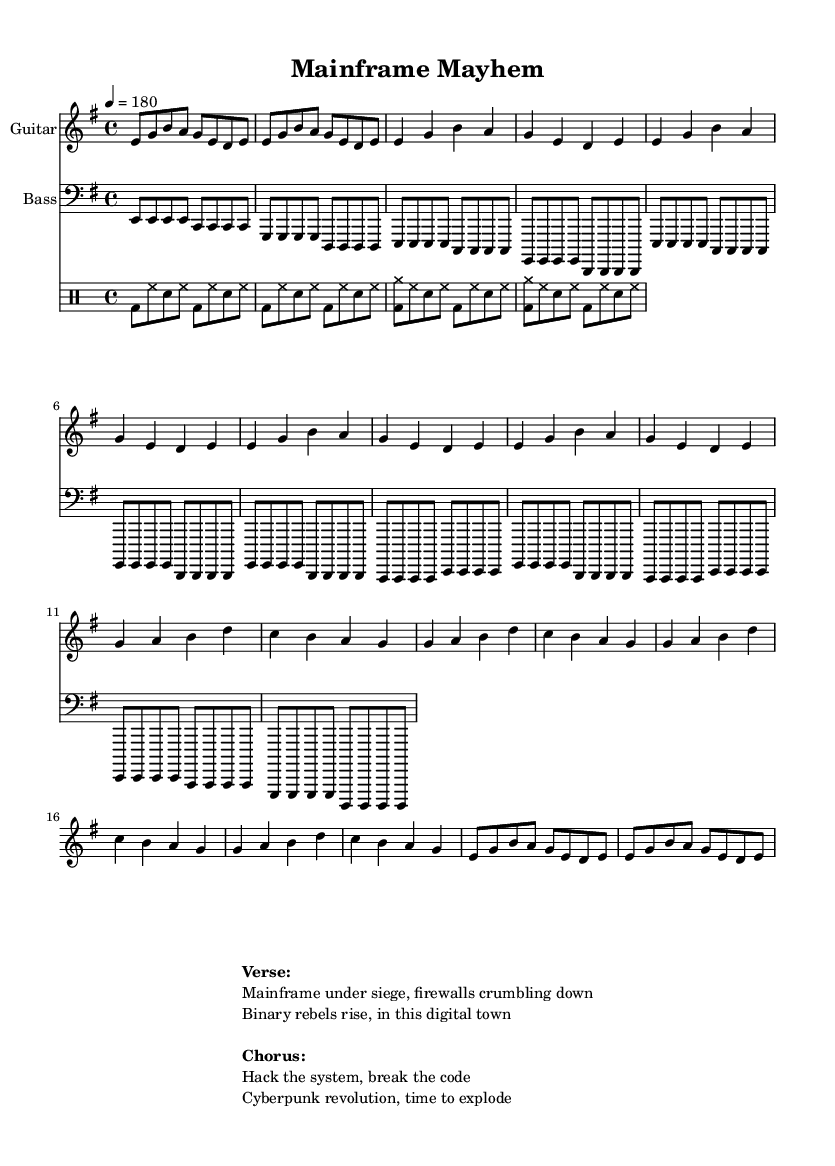What is the key signature of this music? The key signature is E minor, which contains one sharp (F#). The key is indicated at the beginning of the music staff.
Answer: E minor What is the time signature of this music? The time signature is 4/4, indicated at the beginning of the sheet music. This means there are four beats in each measure and the quarter note gets one beat.
Answer: 4/4 What is the tempo marking for this piece? The tempo marking indicates a speed of 180 beats per minute, which sets the fast pace typical for punk rock anthems.
Answer: 180 How many measures are in the verse section? The verse section consists of 4 measures, as indicated by the notation and the repetition specified in the music sheet.
Answer: 4 What type of beat pattern is primarily used in the drums? The primary beat pattern used in the drums is a basic punk beat, which consists of bass and snare sounds alternating with high hats. It's characterized by its straightforward rhythm.
Answer: Basic punk beat What are the main themes explored in the lyrics? The lyrics explore themes of digital rebellion and hacking, as suggested by phrases such as "Mainframe under siege" and "Hack the system." These themes reflect a punk ethos focusing on anti-establishment sentiments within a digital context.
Answer: Digital rebellion 